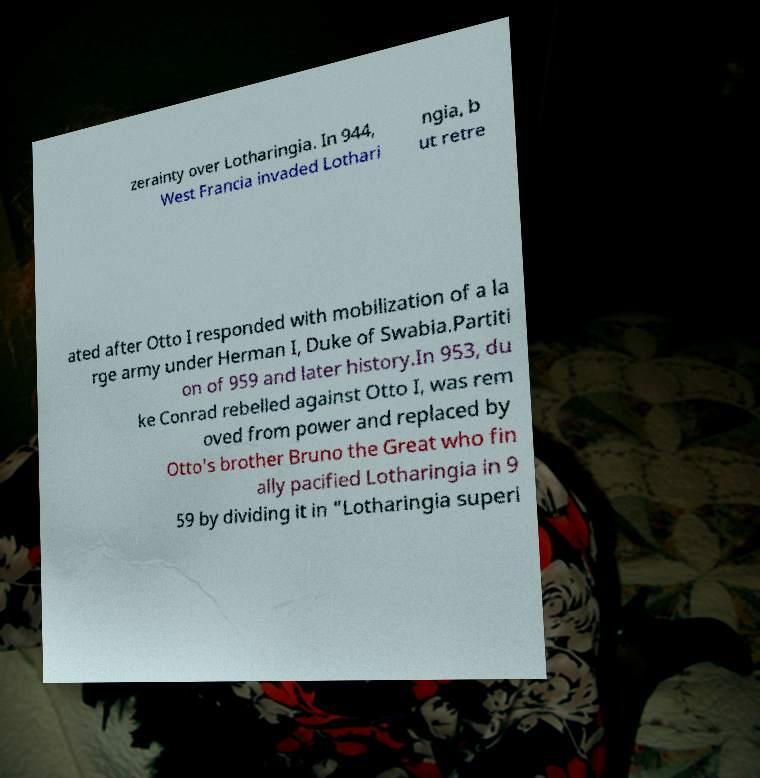Can you accurately transcribe the text from the provided image for me? zerainty over Lotharingia. In 944, West Francia invaded Lothari ngia, b ut retre ated after Otto I responded with mobilization of a la rge army under Herman I, Duke of Swabia.Partiti on of 959 and later history.In 953, du ke Conrad rebelled against Otto I, was rem oved from power and replaced by Otto's brother Bruno the Great who fin ally pacified Lotharingia in 9 59 by dividing it in "Lotharingia superi 